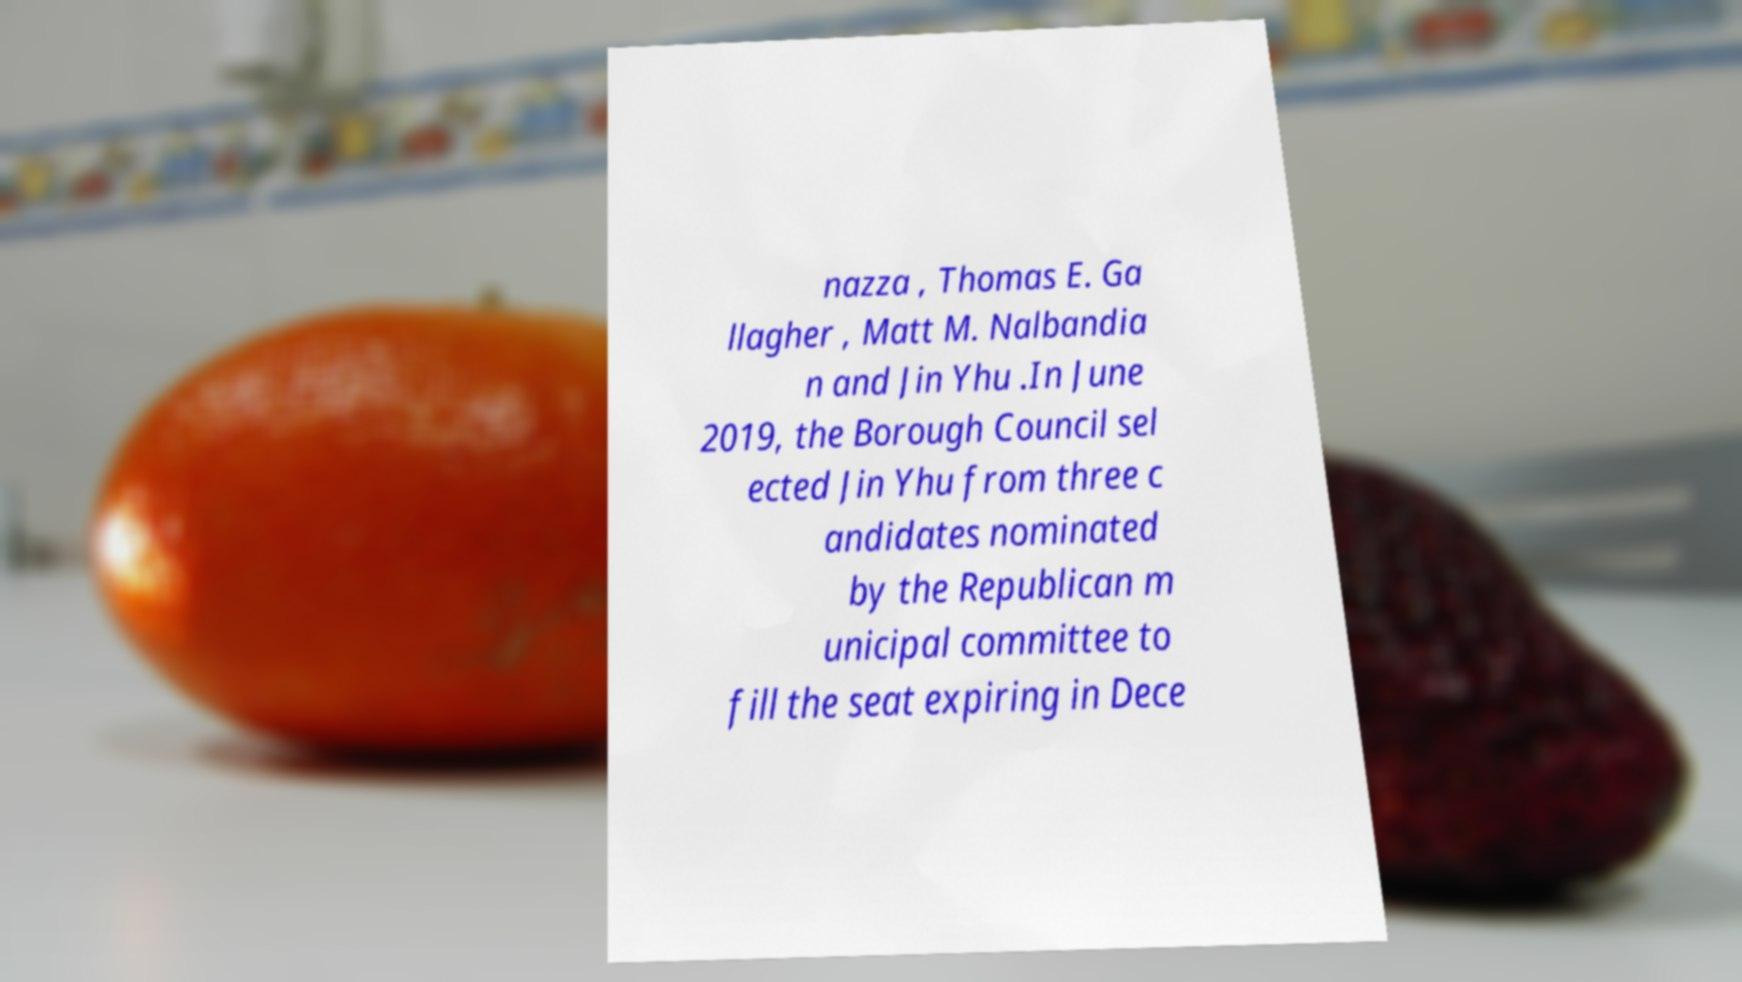For documentation purposes, I need the text within this image transcribed. Could you provide that? nazza , Thomas E. Ga llagher , Matt M. Nalbandia n and Jin Yhu .In June 2019, the Borough Council sel ected Jin Yhu from three c andidates nominated by the Republican m unicipal committee to fill the seat expiring in Dece 